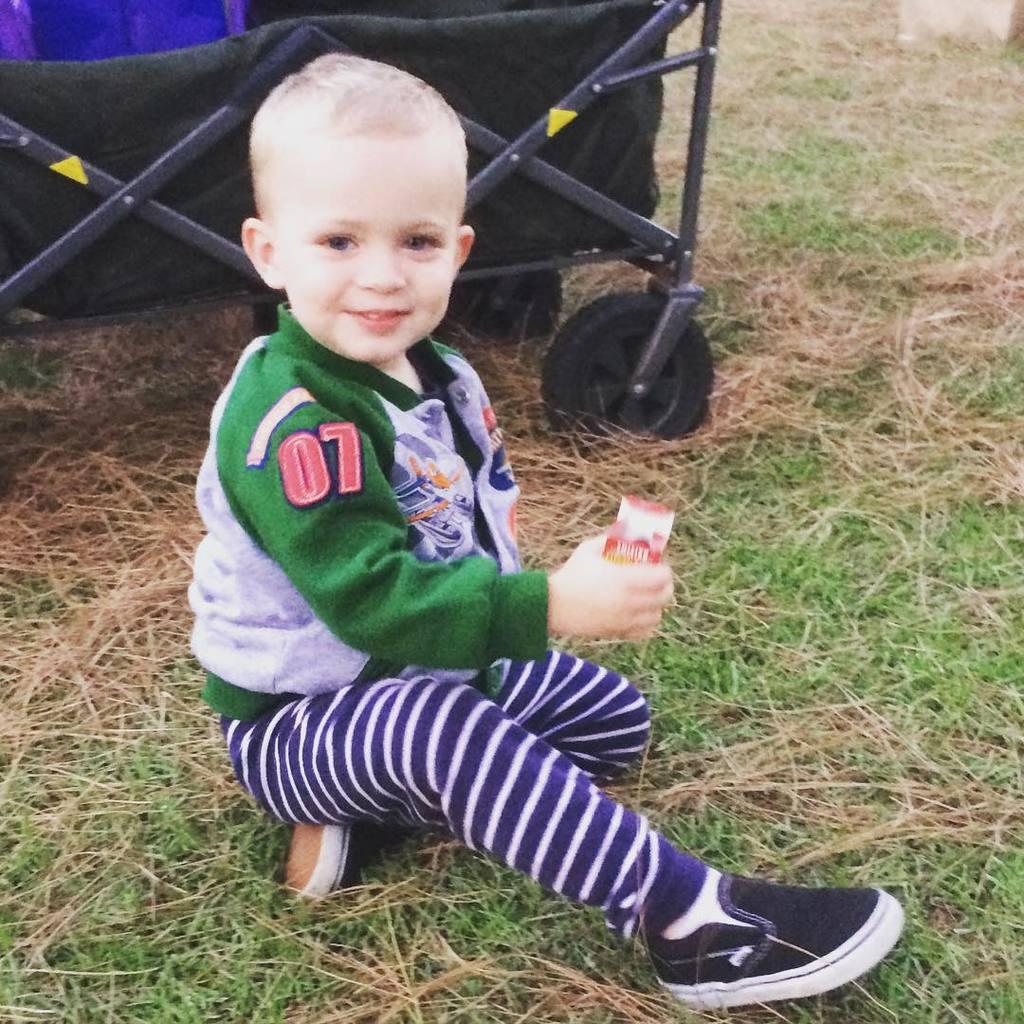Could you give a brief overview of what you see in this image? In this image I can see the person wearing the blue, white and green color dress. The person is sitting on the grass. In the background I can see the black color trolley. 